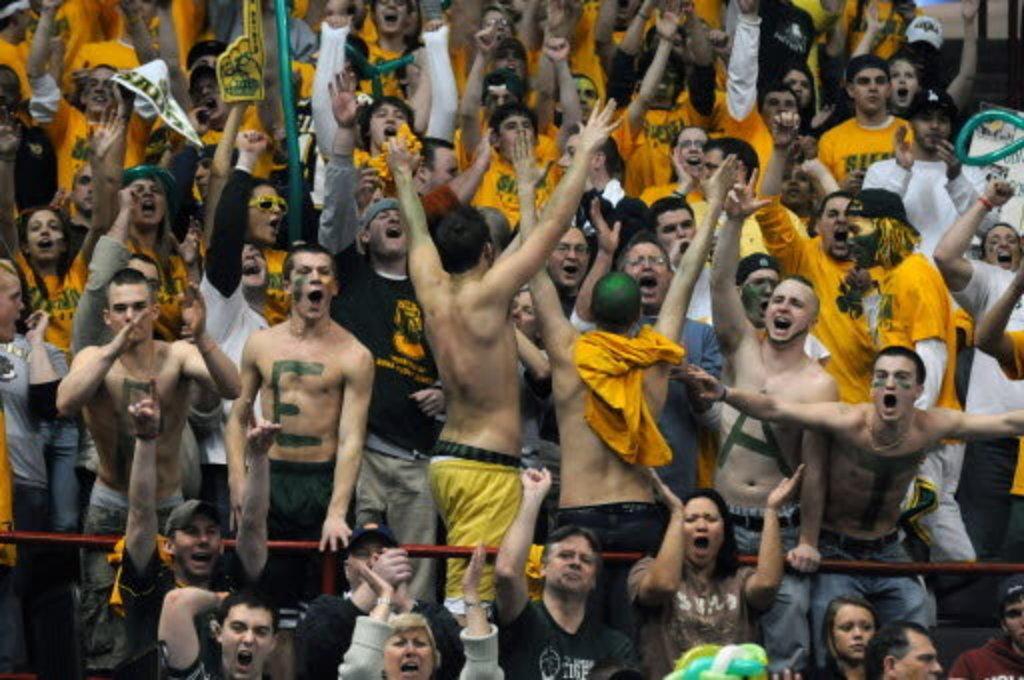In one or two sentences, can you explain what this image depicts? In this image I can see a crowd of people, standing and raising their hands up. It seems to be they are shouting. 